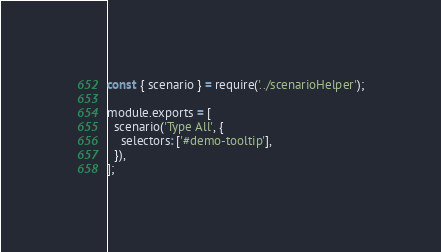Convert code to text. <code><loc_0><loc_0><loc_500><loc_500><_JavaScript_>const { scenario } = require('../scenarioHelper');

module.exports = [
  scenario('Type All', {
    selectors: ['#demo-tooltip'],
  }),
];
</code> 